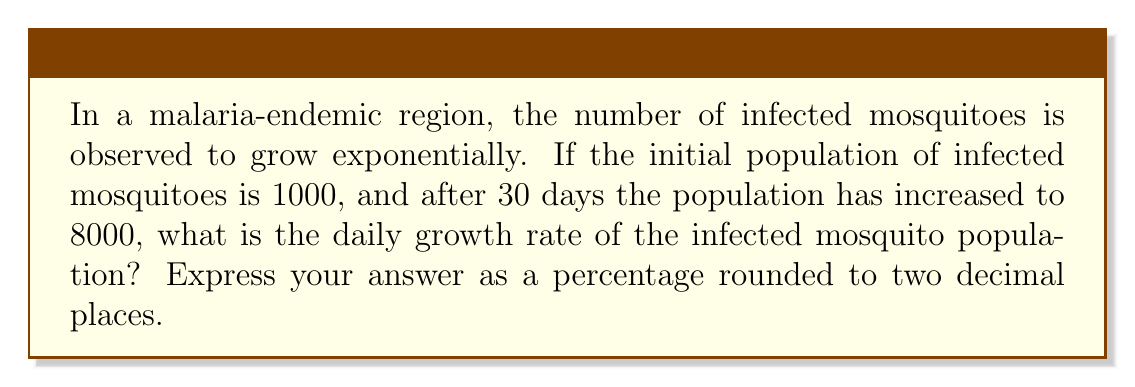Can you answer this question? Let's approach this step-by-step using the exponential growth formula:

1) The exponential growth formula is:
   $$A = P(1 + r)^t$$
   Where:
   $A$ = Final amount
   $P$ = Initial principal balance
   $r$ = Daily growth rate (in decimal form)
   $t$ = Number of days

2) We know:
   $P = 1000$ (initial population)
   $A = 8000$ (final population after 30 days)
   $t = 30$ days

3) Let's substitute these values into the formula:
   $$8000 = 1000(1 + r)^{30}$$

4) Divide both sides by 1000:
   $$8 = (1 + r)^{30}$$

5) Take the 30th root of both sides:
   $$\sqrt[30]{8} = 1 + r$$

6) Subtract 1 from both sides:
   $$\sqrt[30]{8} - 1 = r$$

7) Calculate:
   $$r \approx 0.0699$$

8) Convert to a percentage by multiplying by 100:
   $$0.0699 * 100 \approx 6.99\%$$

9) Round to two decimal places:
   $$6.99\%$$

This means the infected mosquito population is growing by approximately 6.99% each day.
Answer: 6.99% 